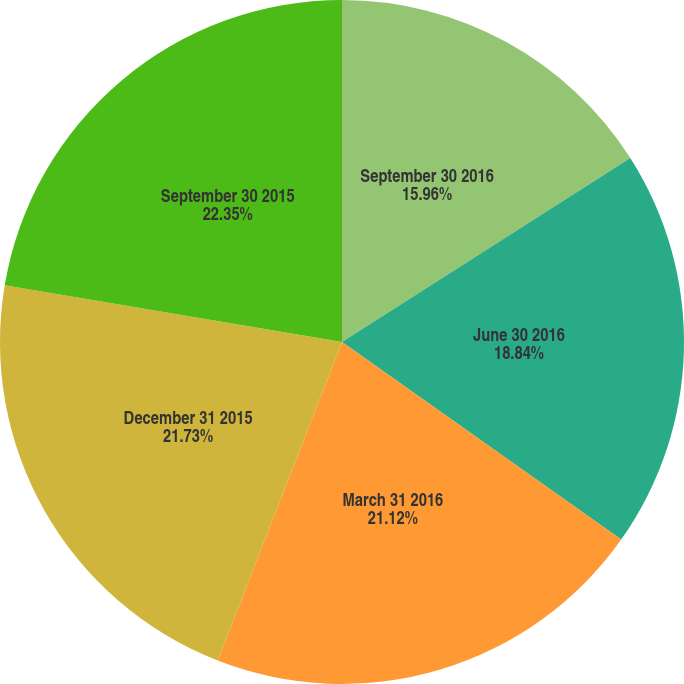Convert chart to OTSL. <chart><loc_0><loc_0><loc_500><loc_500><pie_chart><fcel>September 30 2016<fcel>June 30 2016<fcel>March 31 2016<fcel>December 31 2015<fcel>September 30 2015<nl><fcel>15.96%<fcel>18.84%<fcel>21.12%<fcel>21.73%<fcel>22.35%<nl></chart> 